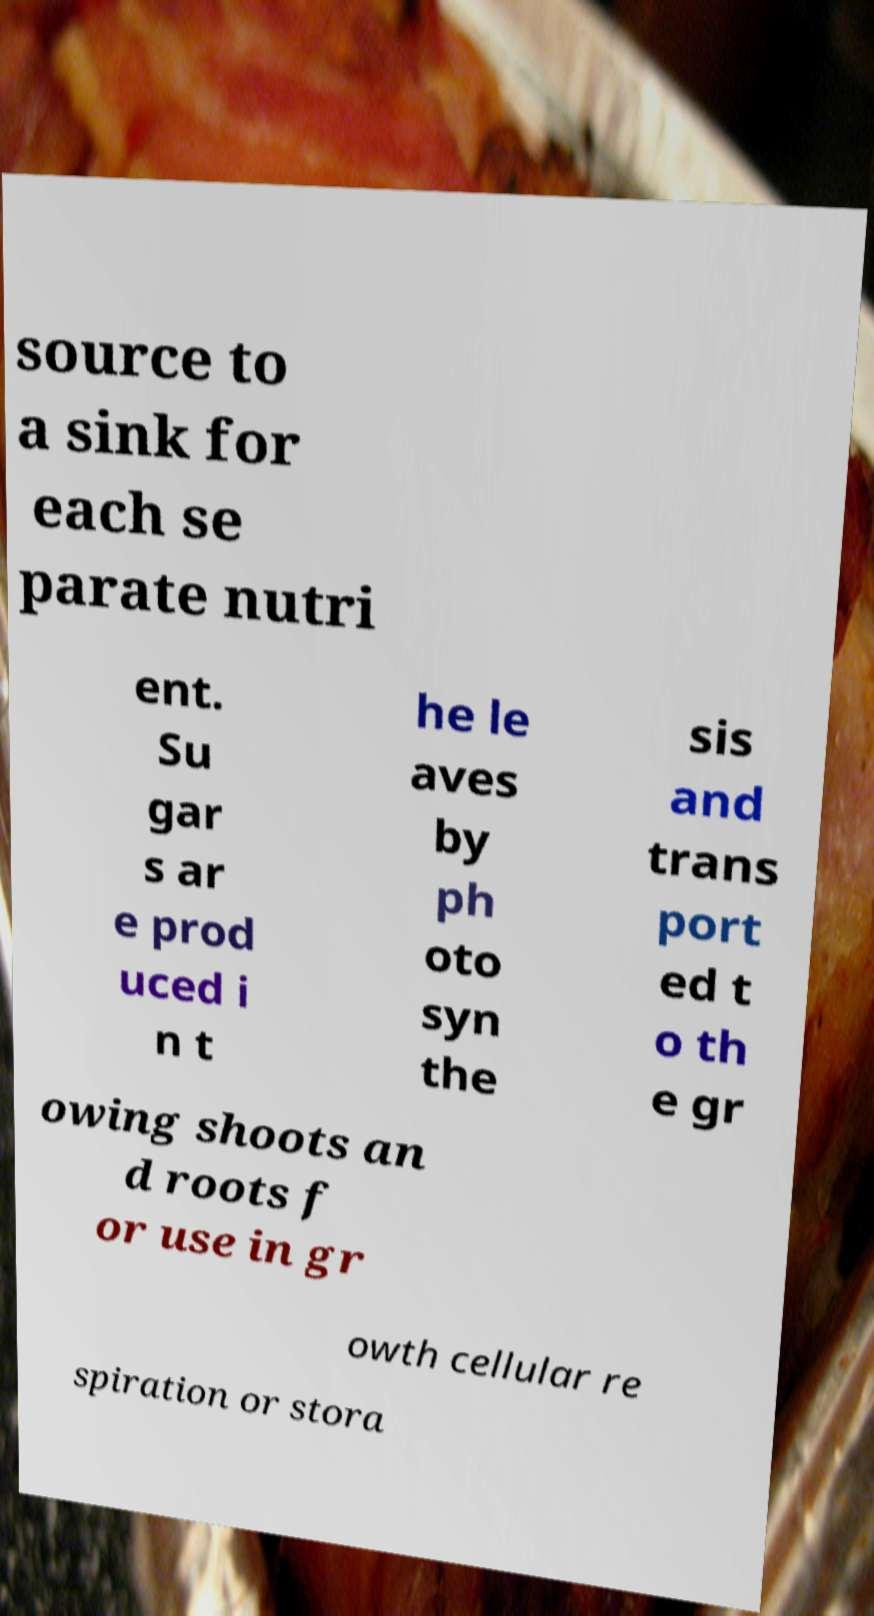Can you read and provide the text displayed in the image?This photo seems to have some interesting text. Can you extract and type it out for me? source to a sink for each se parate nutri ent. Su gar s ar e prod uced i n t he le aves by ph oto syn the sis and trans port ed t o th e gr owing shoots an d roots f or use in gr owth cellular re spiration or stora 